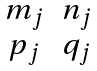Convert formula to latex. <formula><loc_0><loc_0><loc_500><loc_500>\begin{matrix} m _ { j } & n _ { j } \\ p _ { j } & q _ { j } \end{matrix}</formula> 